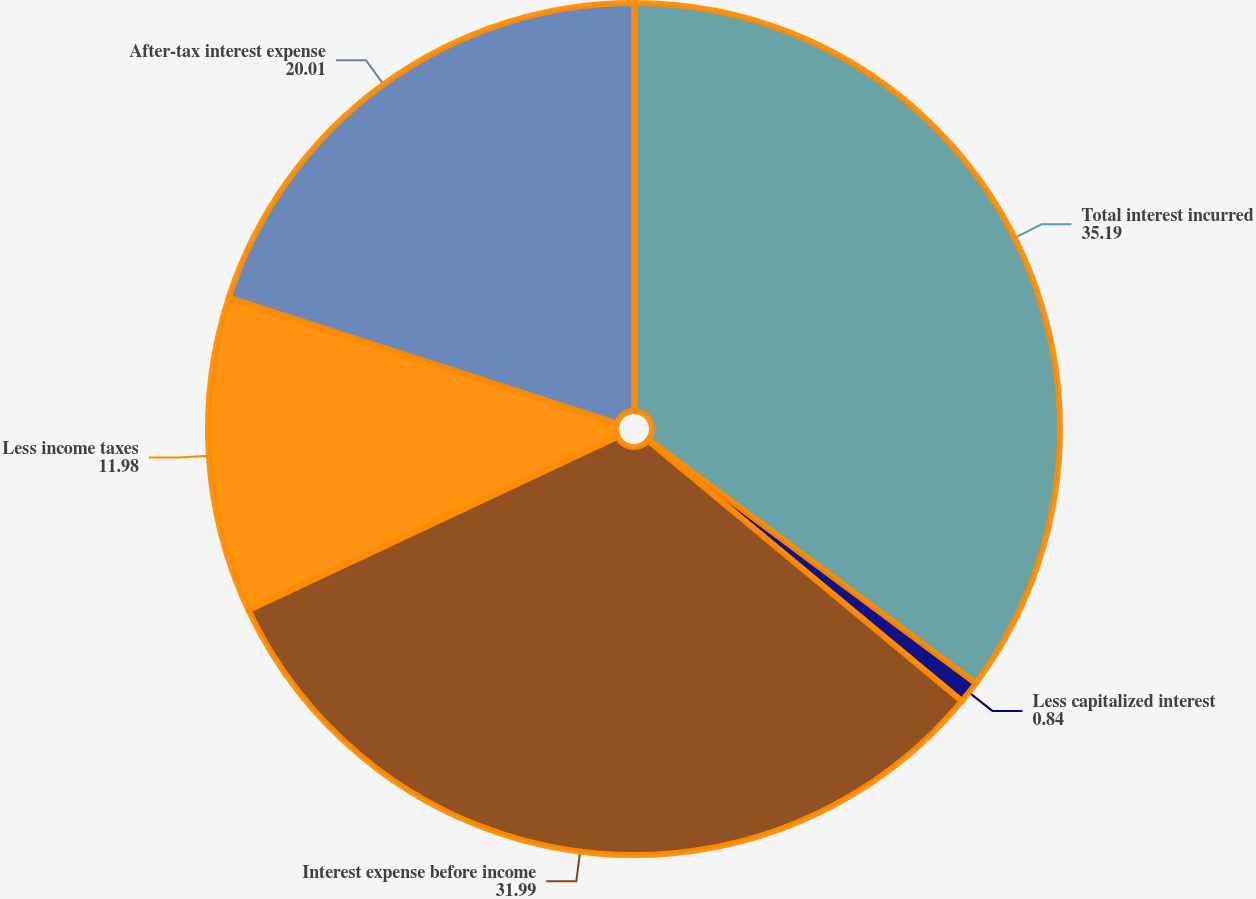Convert chart to OTSL. <chart><loc_0><loc_0><loc_500><loc_500><pie_chart><fcel>Total interest incurred<fcel>Less capitalized interest<fcel>Interest expense before income<fcel>Less income taxes<fcel>After-tax interest expense<nl><fcel>35.19%<fcel>0.84%<fcel>31.99%<fcel>11.98%<fcel>20.01%<nl></chart> 